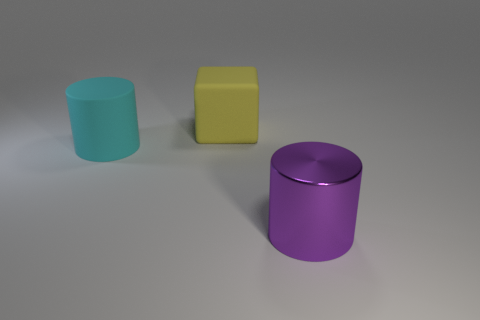Add 1 blue rubber things. How many objects exist? 4 Subtract 1 cylinders. How many cylinders are left? 1 Subtract all cyan spheres. How many blue cubes are left? 0 Subtract all green matte spheres. Subtract all purple cylinders. How many objects are left? 2 Add 1 big cyan cylinders. How many big cyan cylinders are left? 2 Add 1 rubber cubes. How many rubber cubes exist? 2 Subtract 1 cyan cylinders. How many objects are left? 2 Subtract all cylinders. How many objects are left? 1 Subtract all green cylinders. Subtract all cyan spheres. How many cylinders are left? 2 